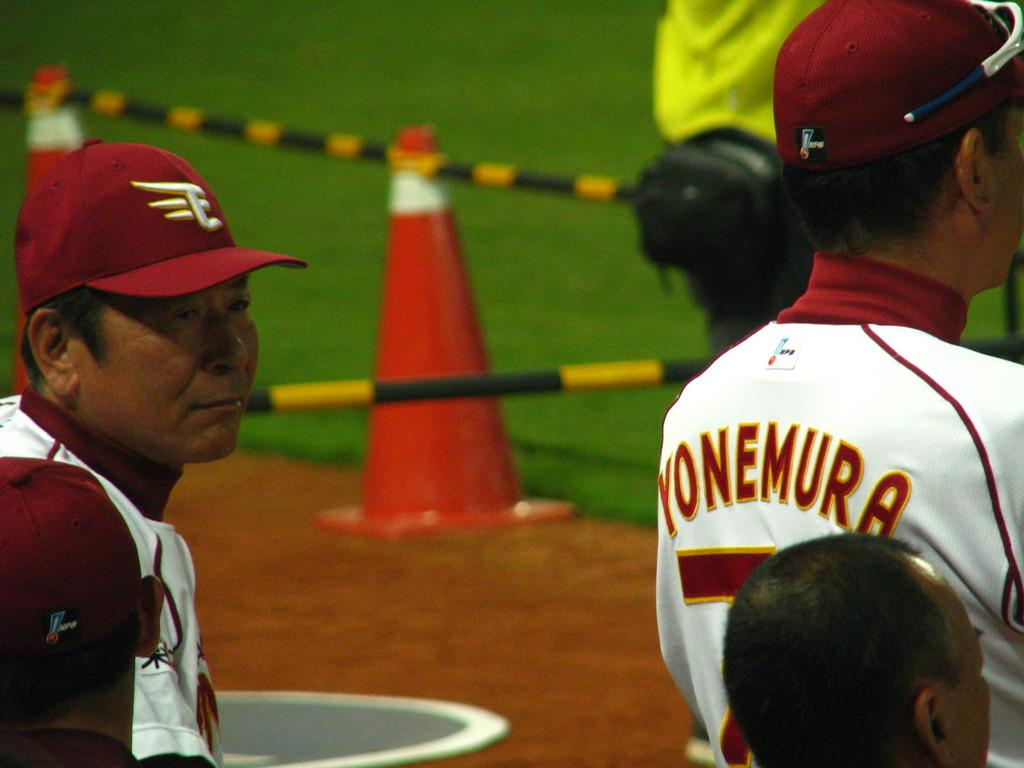<image>
Provide a brief description of the given image. The player shown has the name Yonemura on his back. 